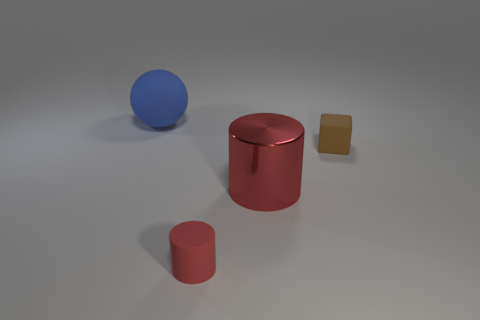Add 1 big green rubber objects. How many objects exist? 5 Subtract all balls. How many objects are left? 3 Add 4 brown rubber things. How many brown rubber things are left? 5 Add 2 tiny cyan things. How many tiny cyan things exist? 2 Subtract 0 cyan blocks. How many objects are left? 4 Subtract all red objects. Subtract all large metal cylinders. How many objects are left? 1 